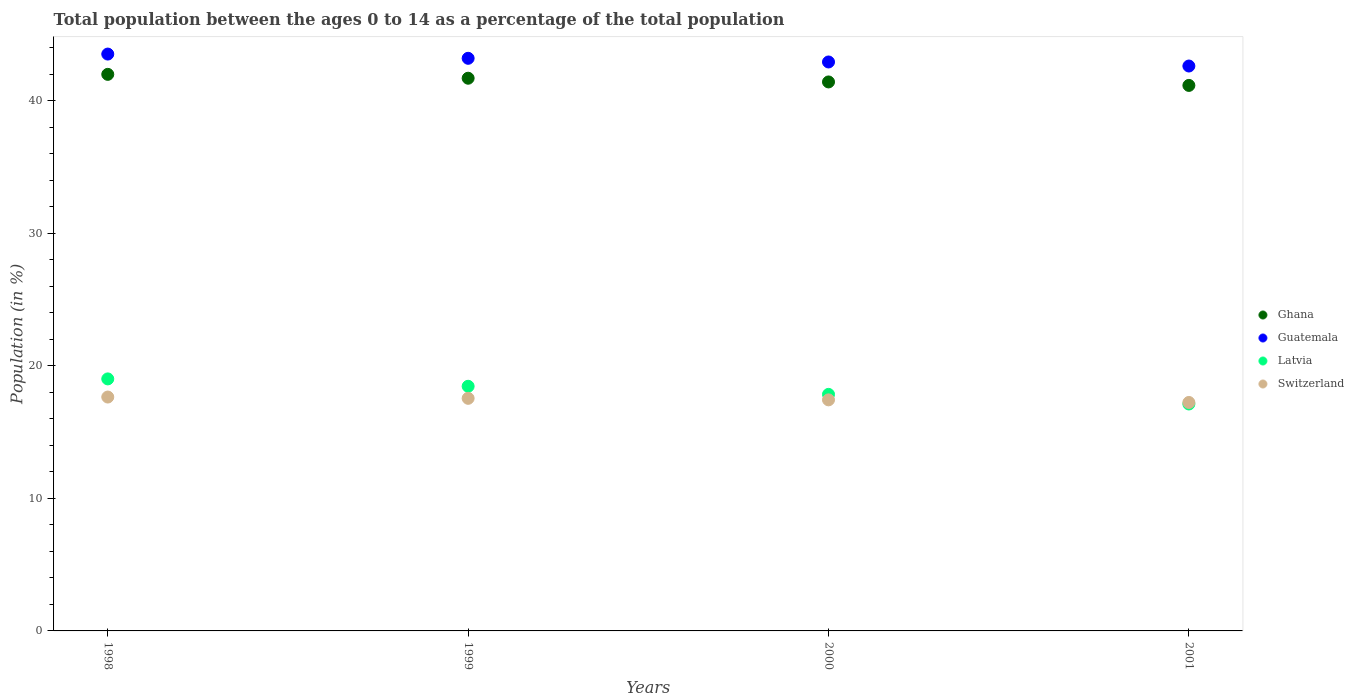How many different coloured dotlines are there?
Provide a succinct answer. 4. What is the percentage of the population ages 0 to 14 in Switzerland in 2001?
Your answer should be compact. 17.24. Across all years, what is the maximum percentage of the population ages 0 to 14 in Switzerland?
Provide a succinct answer. 17.65. Across all years, what is the minimum percentage of the population ages 0 to 14 in Latvia?
Your answer should be very brief. 17.13. In which year was the percentage of the population ages 0 to 14 in Latvia maximum?
Offer a terse response. 1998. What is the total percentage of the population ages 0 to 14 in Guatemala in the graph?
Your answer should be compact. 172.31. What is the difference between the percentage of the population ages 0 to 14 in Ghana in 1999 and that in 2000?
Ensure brevity in your answer.  0.28. What is the difference between the percentage of the population ages 0 to 14 in Switzerland in 1998 and the percentage of the population ages 0 to 14 in Guatemala in 2001?
Offer a very short reply. -24.98. What is the average percentage of the population ages 0 to 14 in Guatemala per year?
Provide a short and direct response. 43.08. In the year 1999, what is the difference between the percentage of the population ages 0 to 14 in Latvia and percentage of the population ages 0 to 14 in Guatemala?
Provide a succinct answer. -24.75. What is the ratio of the percentage of the population ages 0 to 14 in Latvia in 1999 to that in 2000?
Your answer should be compact. 1.03. What is the difference between the highest and the second highest percentage of the population ages 0 to 14 in Switzerland?
Your answer should be very brief. 0.1. What is the difference between the highest and the lowest percentage of the population ages 0 to 14 in Guatemala?
Provide a short and direct response. 0.9. In how many years, is the percentage of the population ages 0 to 14 in Guatemala greater than the average percentage of the population ages 0 to 14 in Guatemala taken over all years?
Offer a terse response. 2. Is the sum of the percentage of the population ages 0 to 14 in Switzerland in 1999 and 2001 greater than the maximum percentage of the population ages 0 to 14 in Latvia across all years?
Offer a terse response. Yes. Is it the case that in every year, the sum of the percentage of the population ages 0 to 14 in Latvia and percentage of the population ages 0 to 14 in Ghana  is greater than the percentage of the population ages 0 to 14 in Switzerland?
Your answer should be very brief. Yes. Is the percentage of the population ages 0 to 14 in Latvia strictly greater than the percentage of the population ages 0 to 14 in Guatemala over the years?
Provide a succinct answer. No. How many dotlines are there?
Make the answer very short. 4. How many years are there in the graph?
Your answer should be compact. 4. Are the values on the major ticks of Y-axis written in scientific E-notation?
Offer a terse response. No. Does the graph contain any zero values?
Give a very brief answer. No. Does the graph contain grids?
Offer a terse response. No. What is the title of the graph?
Provide a succinct answer. Total population between the ages 0 to 14 as a percentage of the total population. What is the Population (in %) of Ghana in 1998?
Ensure brevity in your answer.  42. What is the Population (in %) of Guatemala in 1998?
Make the answer very short. 43.53. What is the Population (in %) in Latvia in 1998?
Provide a succinct answer. 19.02. What is the Population (in %) in Switzerland in 1998?
Offer a terse response. 17.65. What is the Population (in %) of Ghana in 1999?
Offer a very short reply. 41.71. What is the Population (in %) of Guatemala in 1999?
Provide a short and direct response. 43.21. What is the Population (in %) of Latvia in 1999?
Offer a terse response. 18.46. What is the Population (in %) of Switzerland in 1999?
Provide a succinct answer. 17.55. What is the Population (in %) in Ghana in 2000?
Your answer should be compact. 41.43. What is the Population (in %) of Guatemala in 2000?
Provide a succinct answer. 42.94. What is the Population (in %) of Latvia in 2000?
Offer a very short reply. 17.85. What is the Population (in %) in Switzerland in 2000?
Ensure brevity in your answer.  17.44. What is the Population (in %) in Ghana in 2001?
Your response must be concise. 41.17. What is the Population (in %) of Guatemala in 2001?
Make the answer very short. 42.63. What is the Population (in %) of Latvia in 2001?
Provide a succinct answer. 17.13. What is the Population (in %) of Switzerland in 2001?
Keep it short and to the point. 17.24. Across all years, what is the maximum Population (in %) of Ghana?
Your answer should be compact. 42. Across all years, what is the maximum Population (in %) of Guatemala?
Provide a short and direct response. 43.53. Across all years, what is the maximum Population (in %) of Latvia?
Offer a very short reply. 19.02. Across all years, what is the maximum Population (in %) of Switzerland?
Make the answer very short. 17.65. Across all years, what is the minimum Population (in %) in Ghana?
Ensure brevity in your answer.  41.17. Across all years, what is the minimum Population (in %) in Guatemala?
Your answer should be compact. 42.63. Across all years, what is the minimum Population (in %) in Latvia?
Your answer should be compact. 17.13. Across all years, what is the minimum Population (in %) of Switzerland?
Give a very brief answer. 17.24. What is the total Population (in %) in Ghana in the graph?
Provide a short and direct response. 166.31. What is the total Population (in %) in Guatemala in the graph?
Your answer should be compact. 172.31. What is the total Population (in %) in Latvia in the graph?
Provide a short and direct response. 72.46. What is the total Population (in %) of Switzerland in the graph?
Ensure brevity in your answer.  69.88. What is the difference between the Population (in %) of Ghana in 1998 and that in 1999?
Give a very brief answer. 0.29. What is the difference between the Population (in %) of Guatemala in 1998 and that in 1999?
Your answer should be compact. 0.32. What is the difference between the Population (in %) in Latvia in 1998 and that in 1999?
Offer a terse response. 0.56. What is the difference between the Population (in %) in Switzerland in 1998 and that in 1999?
Ensure brevity in your answer.  0.1. What is the difference between the Population (in %) in Ghana in 1998 and that in 2000?
Your answer should be very brief. 0.57. What is the difference between the Population (in %) of Guatemala in 1998 and that in 2000?
Ensure brevity in your answer.  0.6. What is the difference between the Population (in %) of Latvia in 1998 and that in 2000?
Offer a very short reply. 1.17. What is the difference between the Population (in %) in Switzerland in 1998 and that in 2000?
Give a very brief answer. 0.21. What is the difference between the Population (in %) of Ghana in 1998 and that in 2001?
Give a very brief answer. 0.83. What is the difference between the Population (in %) of Guatemala in 1998 and that in 2001?
Give a very brief answer. 0.9. What is the difference between the Population (in %) of Latvia in 1998 and that in 2001?
Offer a terse response. 1.89. What is the difference between the Population (in %) of Switzerland in 1998 and that in 2001?
Offer a very short reply. 0.41. What is the difference between the Population (in %) of Ghana in 1999 and that in 2000?
Provide a short and direct response. 0.28. What is the difference between the Population (in %) in Guatemala in 1999 and that in 2000?
Offer a very short reply. 0.28. What is the difference between the Population (in %) of Latvia in 1999 and that in 2000?
Provide a short and direct response. 0.61. What is the difference between the Population (in %) of Switzerland in 1999 and that in 2000?
Your answer should be very brief. 0.12. What is the difference between the Population (in %) in Ghana in 1999 and that in 2001?
Your response must be concise. 0.54. What is the difference between the Population (in %) in Guatemala in 1999 and that in 2001?
Ensure brevity in your answer.  0.58. What is the difference between the Population (in %) in Latvia in 1999 and that in 2001?
Make the answer very short. 1.34. What is the difference between the Population (in %) in Switzerland in 1999 and that in 2001?
Keep it short and to the point. 0.31. What is the difference between the Population (in %) in Ghana in 2000 and that in 2001?
Your answer should be very brief. 0.26. What is the difference between the Population (in %) of Guatemala in 2000 and that in 2001?
Offer a terse response. 0.31. What is the difference between the Population (in %) in Latvia in 2000 and that in 2001?
Your answer should be compact. 0.73. What is the difference between the Population (in %) in Switzerland in 2000 and that in 2001?
Make the answer very short. 0.2. What is the difference between the Population (in %) in Ghana in 1998 and the Population (in %) in Guatemala in 1999?
Provide a short and direct response. -1.21. What is the difference between the Population (in %) in Ghana in 1998 and the Population (in %) in Latvia in 1999?
Provide a short and direct response. 23.54. What is the difference between the Population (in %) in Ghana in 1998 and the Population (in %) in Switzerland in 1999?
Offer a very short reply. 24.45. What is the difference between the Population (in %) of Guatemala in 1998 and the Population (in %) of Latvia in 1999?
Offer a very short reply. 25.07. What is the difference between the Population (in %) in Guatemala in 1998 and the Population (in %) in Switzerland in 1999?
Give a very brief answer. 25.98. What is the difference between the Population (in %) in Latvia in 1998 and the Population (in %) in Switzerland in 1999?
Ensure brevity in your answer.  1.47. What is the difference between the Population (in %) of Ghana in 1998 and the Population (in %) of Guatemala in 2000?
Make the answer very short. -0.93. What is the difference between the Population (in %) in Ghana in 1998 and the Population (in %) in Latvia in 2000?
Your answer should be very brief. 24.15. What is the difference between the Population (in %) in Ghana in 1998 and the Population (in %) in Switzerland in 2000?
Offer a very short reply. 24.56. What is the difference between the Population (in %) in Guatemala in 1998 and the Population (in %) in Latvia in 2000?
Offer a terse response. 25.68. What is the difference between the Population (in %) in Guatemala in 1998 and the Population (in %) in Switzerland in 2000?
Provide a succinct answer. 26.1. What is the difference between the Population (in %) in Latvia in 1998 and the Population (in %) in Switzerland in 2000?
Ensure brevity in your answer.  1.58. What is the difference between the Population (in %) of Ghana in 1998 and the Population (in %) of Guatemala in 2001?
Keep it short and to the point. -0.63. What is the difference between the Population (in %) in Ghana in 1998 and the Population (in %) in Latvia in 2001?
Provide a succinct answer. 24.88. What is the difference between the Population (in %) in Ghana in 1998 and the Population (in %) in Switzerland in 2001?
Make the answer very short. 24.76. What is the difference between the Population (in %) of Guatemala in 1998 and the Population (in %) of Latvia in 2001?
Provide a succinct answer. 26.41. What is the difference between the Population (in %) of Guatemala in 1998 and the Population (in %) of Switzerland in 2001?
Make the answer very short. 26.29. What is the difference between the Population (in %) in Latvia in 1998 and the Population (in %) in Switzerland in 2001?
Offer a very short reply. 1.78. What is the difference between the Population (in %) of Ghana in 1999 and the Population (in %) of Guatemala in 2000?
Provide a short and direct response. -1.23. What is the difference between the Population (in %) of Ghana in 1999 and the Population (in %) of Latvia in 2000?
Make the answer very short. 23.86. What is the difference between the Population (in %) of Ghana in 1999 and the Population (in %) of Switzerland in 2000?
Your answer should be compact. 24.27. What is the difference between the Population (in %) in Guatemala in 1999 and the Population (in %) in Latvia in 2000?
Your answer should be very brief. 25.36. What is the difference between the Population (in %) in Guatemala in 1999 and the Population (in %) in Switzerland in 2000?
Your response must be concise. 25.78. What is the difference between the Population (in %) in Latvia in 1999 and the Population (in %) in Switzerland in 2000?
Ensure brevity in your answer.  1.02. What is the difference between the Population (in %) in Ghana in 1999 and the Population (in %) in Guatemala in 2001?
Make the answer very short. -0.92. What is the difference between the Population (in %) of Ghana in 1999 and the Population (in %) of Latvia in 2001?
Offer a terse response. 24.59. What is the difference between the Population (in %) in Ghana in 1999 and the Population (in %) in Switzerland in 2001?
Make the answer very short. 24.47. What is the difference between the Population (in %) of Guatemala in 1999 and the Population (in %) of Latvia in 2001?
Offer a very short reply. 26.09. What is the difference between the Population (in %) of Guatemala in 1999 and the Population (in %) of Switzerland in 2001?
Keep it short and to the point. 25.97. What is the difference between the Population (in %) in Latvia in 1999 and the Population (in %) in Switzerland in 2001?
Your answer should be very brief. 1.22. What is the difference between the Population (in %) in Ghana in 2000 and the Population (in %) in Guatemala in 2001?
Make the answer very short. -1.2. What is the difference between the Population (in %) of Ghana in 2000 and the Population (in %) of Latvia in 2001?
Provide a succinct answer. 24.3. What is the difference between the Population (in %) of Ghana in 2000 and the Population (in %) of Switzerland in 2001?
Make the answer very short. 24.19. What is the difference between the Population (in %) of Guatemala in 2000 and the Population (in %) of Latvia in 2001?
Your answer should be very brief. 25.81. What is the difference between the Population (in %) in Guatemala in 2000 and the Population (in %) in Switzerland in 2001?
Keep it short and to the point. 25.7. What is the difference between the Population (in %) in Latvia in 2000 and the Population (in %) in Switzerland in 2001?
Offer a very short reply. 0.61. What is the average Population (in %) of Ghana per year?
Ensure brevity in your answer.  41.58. What is the average Population (in %) of Guatemala per year?
Make the answer very short. 43.08. What is the average Population (in %) in Latvia per year?
Provide a succinct answer. 18.11. What is the average Population (in %) of Switzerland per year?
Your answer should be compact. 17.47. In the year 1998, what is the difference between the Population (in %) in Ghana and Population (in %) in Guatemala?
Provide a succinct answer. -1.53. In the year 1998, what is the difference between the Population (in %) in Ghana and Population (in %) in Latvia?
Ensure brevity in your answer.  22.98. In the year 1998, what is the difference between the Population (in %) of Ghana and Population (in %) of Switzerland?
Your answer should be compact. 24.35. In the year 1998, what is the difference between the Population (in %) of Guatemala and Population (in %) of Latvia?
Provide a succinct answer. 24.51. In the year 1998, what is the difference between the Population (in %) of Guatemala and Population (in %) of Switzerland?
Ensure brevity in your answer.  25.88. In the year 1998, what is the difference between the Population (in %) of Latvia and Population (in %) of Switzerland?
Make the answer very short. 1.37. In the year 1999, what is the difference between the Population (in %) of Ghana and Population (in %) of Guatemala?
Offer a terse response. -1.5. In the year 1999, what is the difference between the Population (in %) of Ghana and Population (in %) of Latvia?
Make the answer very short. 23.25. In the year 1999, what is the difference between the Population (in %) of Ghana and Population (in %) of Switzerland?
Your response must be concise. 24.16. In the year 1999, what is the difference between the Population (in %) in Guatemala and Population (in %) in Latvia?
Provide a short and direct response. 24.75. In the year 1999, what is the difference between the Population (in %) of Guatemala and Population (in %) of Switzerland?
Your answer should be compact. 25.66. In the year 1999, what is the difference between the Population (in %) in Latvia and Population (in %) in Switzerland?
Offer a very short reply. 0.91. In the year 2000, what is the difference between the Population (in %) in Ghana and Population (in %) in Guatemala?
Offer a very short reply. -1.51. In the year 2000, what is the difference between the Population (in %) of Ghana and Population (in %) of Latvia?
Your answer should be very brief. 23.58. In the year 2000, what is the difference between the Population (in %) of Ghana and Population (in %) of Switzerland?
Give a very brief answer. 23.99. In the year 2000, what is the difference between the Population (in %) in Guatemala and Population (in %) in Latvia?
Provide a short and direct response. 25.09. In the year 2000, what is the difference between the Population (in %) in Guatemala and Population (in %) in Switzerland?
Keep it short and to the point. 25.5. In the year 2000, what is the difference between the Population (in %) of Latvia and Population (in %) of Switzerland?
Your answer should be very brief. 0.41. In the year 2001, what is the difference between the Population (in %) in Ghana and Population (in %) in Guatemala?
Your answer should be compact. -1.46. In the year 2001, what is the difference between the Population (in %) in Ghana and Population (in %) in Latvia?
Offer a very short reply. 24.04. In the year 2001, what is the difference between the Population (in %) of Ghana and Population (in %) of Switzerland?
Your answer should be very brief. 23.93. In the year 2001, what is the difference between the Population (in %) in Guatemala and Population (in %) in Latvia?
Offer a very short reply. 25.51. In the year 2001, what is the difference between the Population (in %) in Guatemala and Population (in %) in Switzerland?
Offer a terse response. 25.39. In the year 2001, what is the difference between the Population (in %) of Latvia and Population (in %) of Switzerland?
Offer a very short reply. -0.12. What is the ratio of the Population (in %) of Guatemala in 1998 to that in 1999?
Your answer should be very brief. 1.01. What is the ratio of the Population (in %) of Latvia in 1998 to that in 1999?
Provide a short and direct response. 1.03. What is the ratio of the Population (in %) of Ghana in 1998 to that in 2000?
Give a very brief answer. 1.01. What is the ratio of the Population (in %) in Guatemala in 1998 to that in 2000?
Your response must be concise. 1.01. What is the ratio of the Population (in %) in Latvia in 1998 to that in 2000?
Your response must be concise. 1.07. What is the ratio of the Population (in %) in Switzerland in 1998 to that in 2000?
Offer a very short reply. 1.01. What is the ratio of the Population (in %) of Ghana in 1998 to that in 2001?
Offer a terse response. 1.02. What is the ratio of the Population (in %) in Guatemala in 1998 to that in 2001?
Offer a terse response. 1.02. What is the ratio of the Population (in %) of Latvia in 1998 to that in 2001?
Ensure brevity in your answer.  1.11. What is the ratio of the Population (in %) in Switzerland in 1998 to that in 2001?
Offer a terse response. 1.02. What is the ratio of the Population (in %) in Ghana in 1999 to that in 2000?
Provide a short and direct response. 1.01. What is the ratio of the Population (in %) in Guatemala in 1999 to that in 2000?
Your answer should be very brief. 1.01. What is the ratio of the Population (in %) in Latvia in 1999 to that in 2000?
Provide a succinct answer. 1.03. What is the ratio of the Population (in %) of Switzerland in 1999 to that in 2000?
Provide a succinct answer. 1.01. What is the ratio of the Population (in %) of Ghana in 1999 to that in 2001?
Your answer should be very brief. 1.01. What is the ratio of the Population (in %) of Guatemala in 1999 to that in 2001?
Provide a succinct answer. 1.01. What is the ratio of the Population (in %) in Latvia in 1999 to that in 2001?
Make the answer very short. 1.08. What is the ratio of the Population (in %) of Switzerland in 1999 to that in 2001?
Provide a succinct answer. 1.02. What is the ratio of the Population (in %) of Ghana in 2000 to that in 2001?
Keep it short and to the point. 1.01. What is the ratio of the Population (in %) of Guatemala in 2000 to that in 2001?
Your answer should be very brief. 1.01. What is the ratio of the Population (in %) in Latvia in 2000 to that in 2001?
Ensure brevity in your answer.  1.04. What is the ratio of the Population (in %) in Switzerland in 2000 to that in 2001?
Provide a short and direct response. 1.01. What is the difference between the highest and the second highest Population (in %) of Ghana?
Your answer should be very brief. 0.29. What is the difference between the highest and the second highest Population (in %) in Guatemala?
Ensure brevity in your answer.  0.32. What is the difference between the highest and the second highest Population (in %) in Latvia?
Provide a succinct answer. 0.56. What is the difference between the highest and the second highest Population (in %) of Switzerland?
Provide a short and direct response. 0.1. What is the difference between the highest and the lowest Population (in %) of Ghana?
Your answer should be compact. 0.83. What is the difference between the highest and the lowest Population (in %) in Guatemala?
Offer a very short reply. 0.9. What is the difference between the highest and the lowest Population (in %) in Latvia?
Your answer should be very brief. 1.89. What is the difference between the highest and the lowest Population (in %) in Switzerland?
Ensure brevity in your answer.  0.41. 